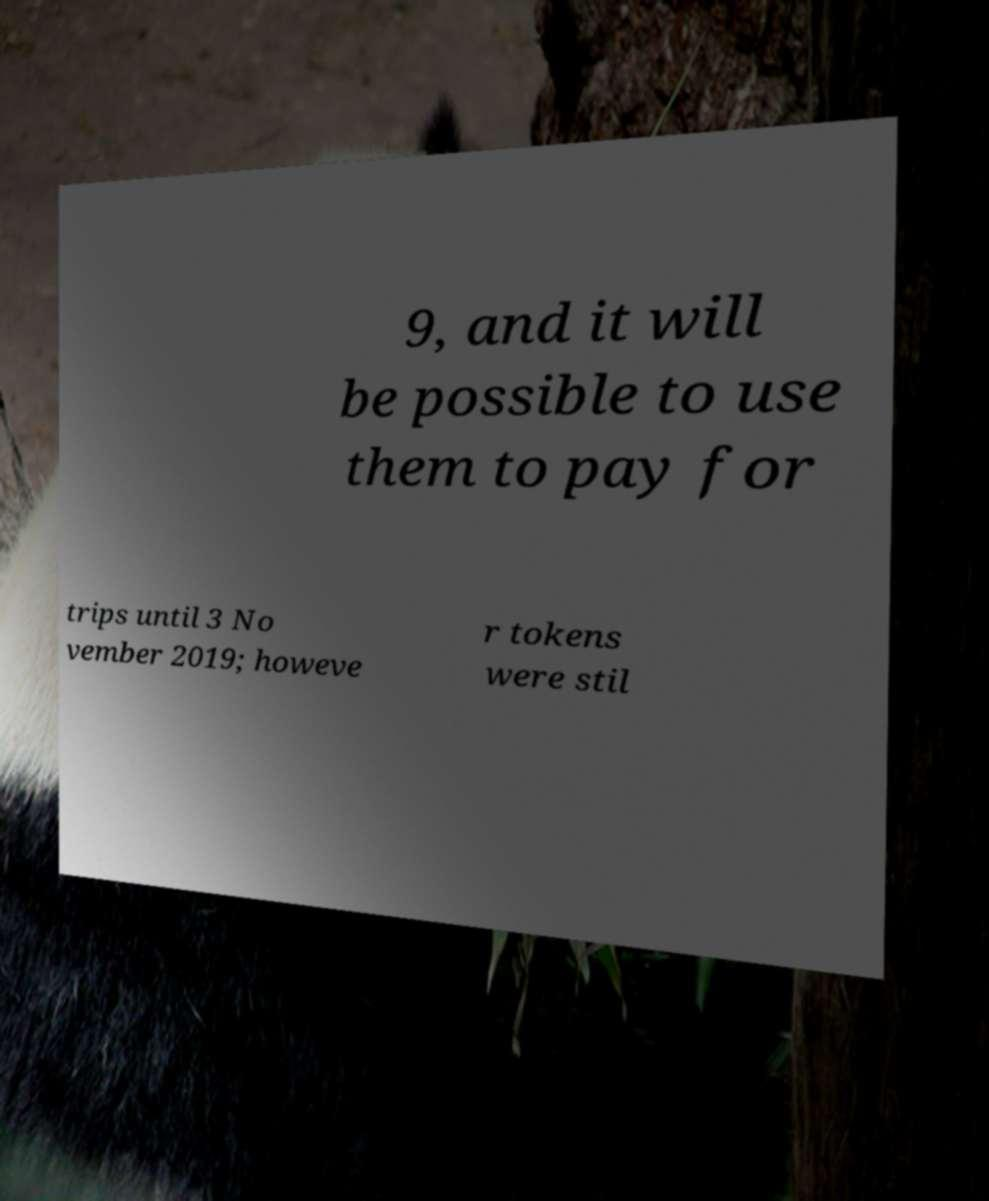Please identify and transcribe the text found in this image. 9, and it will be possible to use them to pay for trips until 3 No vember 2019; howeve r tokens were stil 